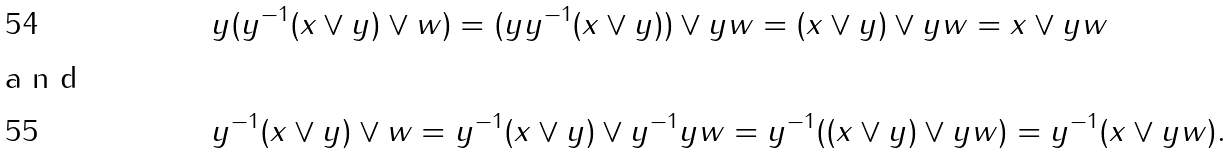<formula> <loc_0><loc_0><loc_500><loc_500>& y ( y ^ { - 1 } ( x \vee y ) \vee w ) = ( y y ^ { - 1 } ( x \vee y ) ) \vee y w = ( x \vee y ) \vee y w = x \vee y w \\ \intertext { a n d } & y ^ { - 1 } ( x \vee y ) \vee w = y ^ { - 1 } ( x \vee y ) \vee y ^ { - 1 } y w = y ^ { - 1 } ( ( x \vee y ) \vee y w ) = y ^ { - 1 } ( x \vee y w ) .</formula> 